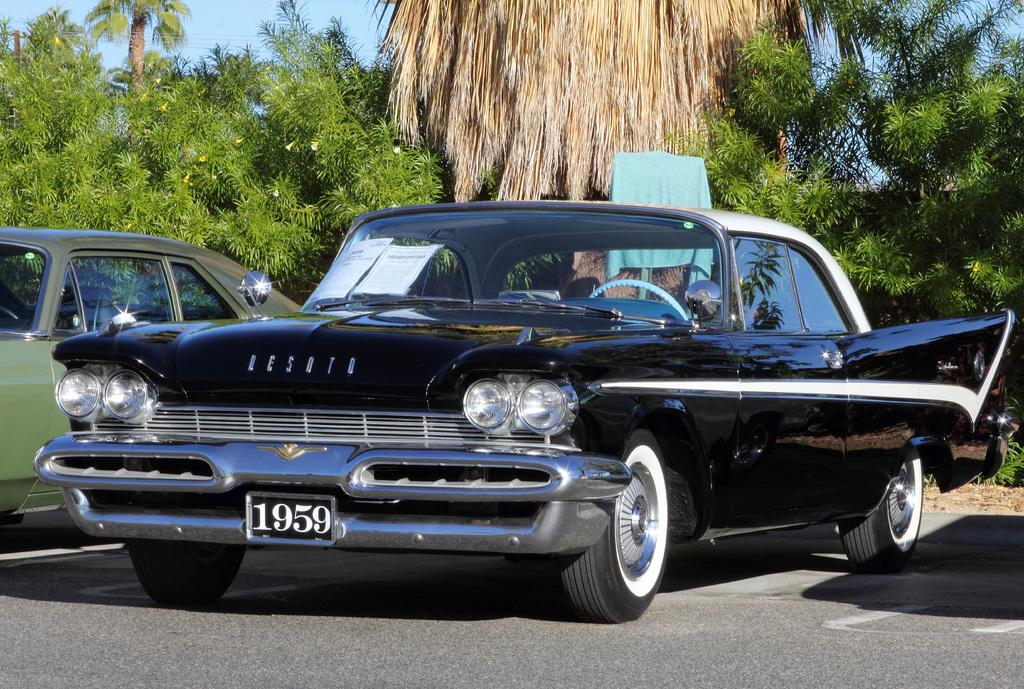What can be seen on the road in the image? There are two cars on the road in the image. What type of natural scenery is visible in the background? There are trees in the background of the image. What else can be seen in the background of the image? The sky is visible in the background of the image. What type of crime is being committed in the image? There is no crime being committed in the image; it simply shows two cars on the road and trees and sky in the background. 